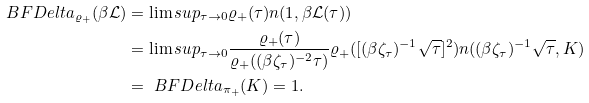<formula> <loc_0><loc_0><loc_500><loc_500>\ B F D e l t a _ { \varrho _ { + } } ( \beta \mathcal { L } ) & = \lim s u p _ { \tau \to 0 } \varrho _ { + } ( \tau ) n ( 1 , \beta \mathcal { L } ( \tau ) ) \\ & = \lim s u p _ { \tau \to 0 } \frac { \varrho _ { + } ( \tau ) } { \varrho _ { + } ( ( \beta \zeta _ { \tau } ) ^ { - 2 } \tau ) } \varrho _ { + } ( [ ( \beta \zeta _ { \tau } ) ^ { - 1 } \sqrt { \tau } ] ^ { 2 } ) n ( ( \beta \zeta _ { \tau } ) ^ { - 1 } \sqrt { \tau } , K ) \\ & = \ B F D e l t a _ { \pi _ { + } } ( K ) = 1 .</formula> 